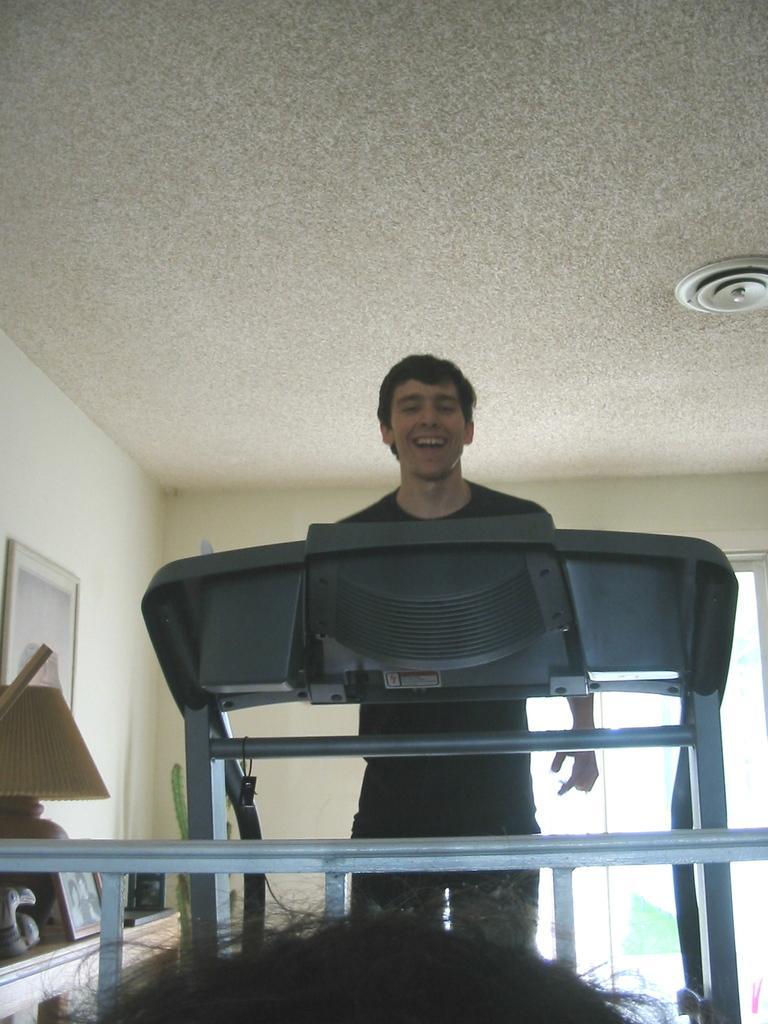In one or two sentences, can you explain what this image depicts? Here we can see a person. On this table there is a picture, lamp and objects. Picture is on the wall. 